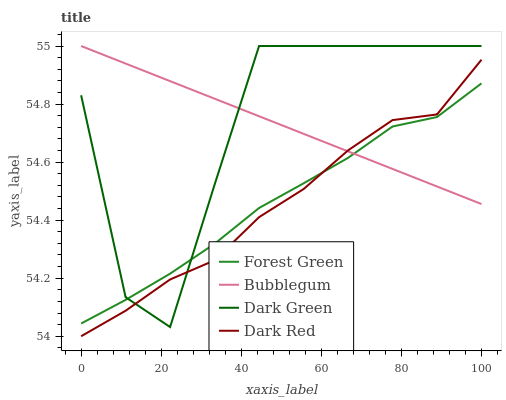Does Dark Red have the minimum area under the curve?
Answer yes or no. Yes. Does Dark Green have the maximum area under the curve?
Answer yes or no. Yes. Does Forest Green have the minimum area under the curve?
Answer yes or no. No. Does Forest Green have the maximum area under the curve?
Answer yes or no. No. Is Bubblegum the smoothest?
Answer yes or no. Yes. Is Dark Green the roughest?
Answer yes or no. Yes. Is Forest Green the smoothest?
Answer yes or no. No. Is Forest Green the roughest?
Answer yes or no. No. Does Dark Red have the lowest value?
Answer yes or no. Yes. Does Forest Green have the lowest value?
Answer yes or no. No. Does Dark Green have the highest value?
Answer yes or no. Yes. Does Forest Green have the highest value?
Answer yes or no. No. Does Dark Red intersect Forest Green?
Answer yes or no. Yes. Is Dark Red less than Forest Green?
Answer yes or no. No. Is Dark Red greater than Forest Green?
Answer yes or no. No. 